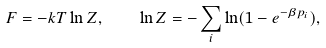<formula> <loc_0><loc_0><loc_500><loc_500>F = - k T \ln Z , \quad \ln Z = - \sum _ { i } \ln ( 1 - e ^ { - \beta p _ { i } } ) ,</formula> 